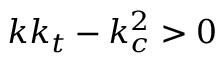Convert formula to latex. <formula><loc_0><loc_0><loc_500><loc_500>k k _ { t } - k _ { c } ^ { 2 } > 0</formula> 